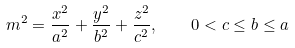Convert formula to latex. <formula><loc_0><loc_0><loc_500><loc_500>m ^ { 2 } = \frac { x ^ { 2 } } { a ^ { 2 } } + \frac { y ^ { 2 } } { b ^ { 2 } } + \frac { z ^ { 2 } } { c ^ { 2 } } , \quad 0 < c \leq b \leq a</formula> 